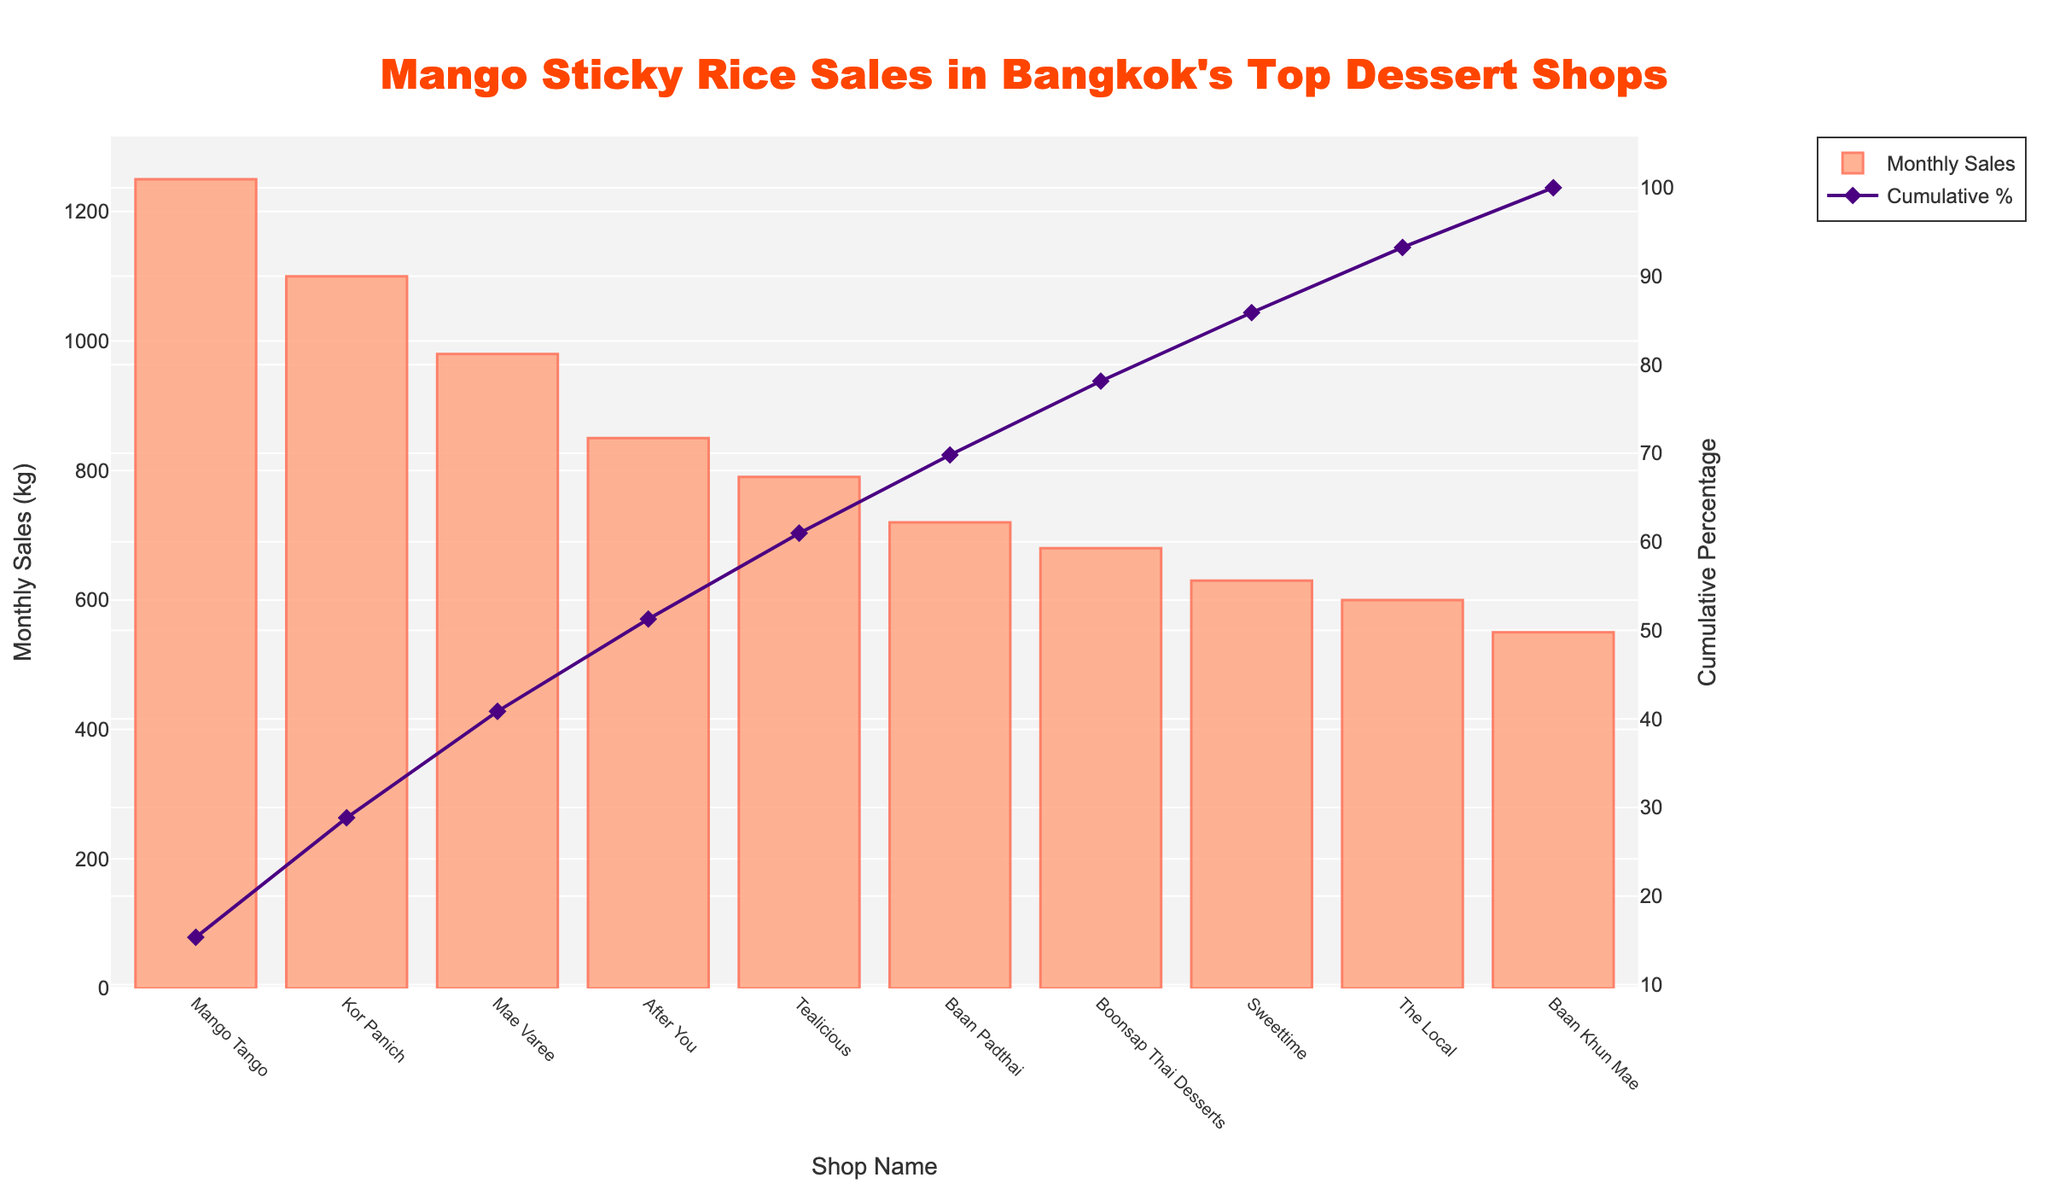Which dessert shop has the highest monthly sales? By examining the height of the bars, we can see that the tallest bar corresponds to "Mango Tango," indicating it has the highest monthly sales.
Answer: Mango Tango Which dessert shop has the lowest monthly sales? The shortest bar represents the dessert shop with the lowest monthly sales, and that shop is "Baan Khun Mae."
Answer: Baan Khun Mae What is the combined monthly sales of "Mae Varee" and "Kor Panich"? The monthly sales for "Mae Varee" is 980 kg and for "Kor Panich" is 1100 kg. Summing these values gives 980 + 1100 = 2080 kg.
Answer: 2080 kg How much more does "Mango Tango" sell compared to "After You"? "Mango Tango" sells 1250 kg, and "After You" sells 850 kg. The difference is 1250 - 850 = 400 kg.
Answer: 400 kg What is the cumulative percentage of sales achieved by the top 3 shops? The monthly sales for the top 3 shops ("Mango Tango," "Kor Panich," and "Mae Varee") are 1250 kg, 1100 kg, and 980 kg respectively. Their cumulative sales are 1250 + 1100 + 980 = 3330 kg. The total sales of all shops are 7550 kg. Thus, the cumulative percentage is (3330 / 7550) * 100 ≈ 44.11%.
Answer: ~44.11% Which shops have monthly sales between 600 kg and 800 kg? Checking the heights of the bars between 600 kg and 800 kg, we find "Tealicious," "Baan Padthai," and "Sweettime" fall in that range.
Answer: Tealicious, Baan Padthai, Sweettime What is the average monthly sales of all the dessert shops? Adding all the sales values: 1250 + 980 + 1100 + 850 + 720 + 680 + 790 + 600 + 550 + 630 = 7550 kg. There are 10 shops, so the average is 7550 / 10 = 755 kg.
Answer: 755 kg Which shop has a cumulative percentage closest to 50%? By examining the cumulative percentage line, "Kor Panich" appears to have a cumulative percentage slightly above 40%, which is closest to 50% compared to other shops.
Answer: Kor Panich 